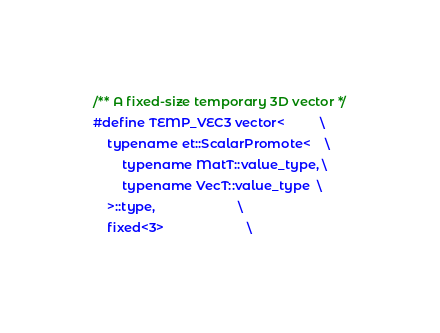<code> <loc_0><loc_0><loc_500><loc_500><_C_>
/** A fixed-size temporary 3D vector */
#define TEMP_VEC3 vector<          \
    typename et::ScalarPromote<    \
        typename MatT::value_type, \
        typename VecT::value_type  \
    >::type,                       \
    fixed<3>                       \</code> 